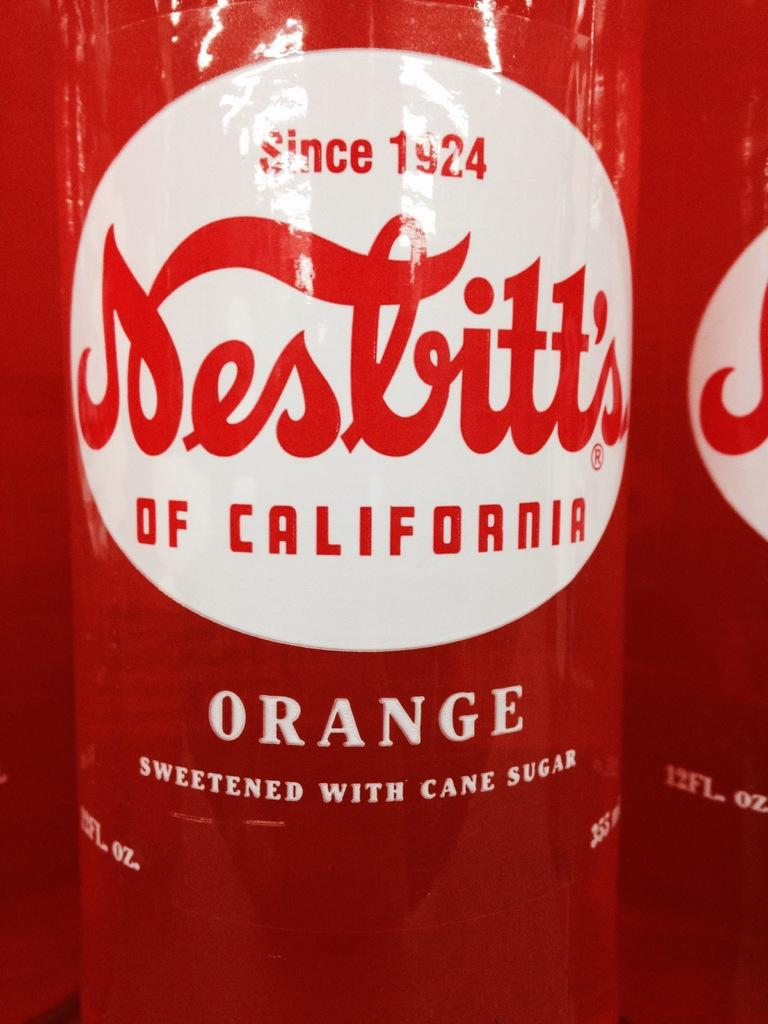<image>
Create a compact narrative representing the image presented. the year 1924 is on the red bottle 